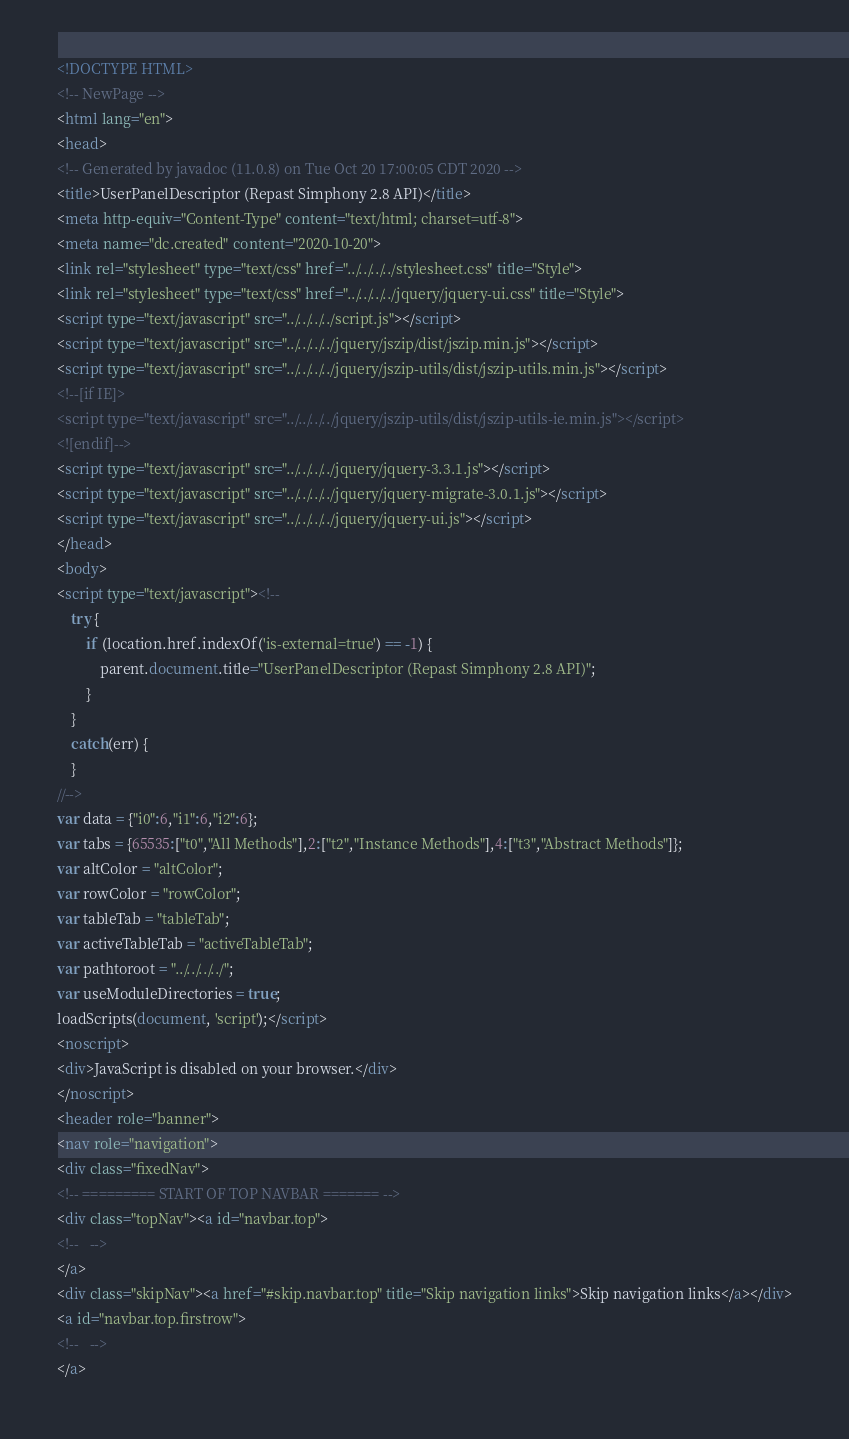<code> <loc_0><loc_0><loc_500><loc_500><_HTML_><!DOCTYPE HTML>
<!-- NewPage -->
<html lang="en">
<head>
<!-- Generated by javadoc (11.0.8) on Tue Oct 20 17:00:05 CDT 2020 -->
<title>UserPanelDescriptor (Repast Simphony 2.8 API)</title>
<meta http-equiv="Content-Type" content="text/html; charset=utf-8">
<meta name="dc.created" content="2020-10-20">
<link rel="stylesheet" type="text/css" href="../../../../stylesheet.css" title="Style">
<link rel="stylesheet" type="text/css" href="../../../../jquery/jquery-ui.css" title="Style">
<script type="text/javascript" src="../../../../script.js"></script>
<script type="text/javascript" src="../../../../jquery/jszip/dist/jszip.min.js"></script>
<script type="text/javascript" src="../../../../jquery/jszip-utils/dist/jszip-utils.min.js"></script>
<!--[if IE]>
<script type="text/javascript" src="../../../../jquery/jszip-utils/dist/jszip-utils-ie.min.js"></script>
<![endif]-->
<script type="text/javascript" src="../../../../jquery/jquery-3.3.1.js"></script>
<script type="text/javascript" src="../../../../jquery/jquery-migrate-3.0.1.js"></script>
<script type="text/javascript" src="../../../../jquery/jquery-ui.js"></script>
</head>
<body>
<script type="text/javascript"><!--
    try {
        if (location.href.indexOf('is-external=true') == -1) {
            parent.document.title="UserPanelDescriptor (Repast Simphony 2.8 API)";
        }
    }
    catch(err) {
    }
//-->
var data = {"i0":6,"i1":6,"i2":6};
var tabs = {65535:["t0","All Methods"],2:["t2","Instance Methods"],4:["t3","Abstract Methods"]};
var altColor = "altColor";
var rowColor = "rowColor";
var tableTab = "tableTab";
var activeTableTab = "activeTableTab";
var pathtoroot = "../../../../";
var useModuleDirectories = true;
loadScripts(document, 'script');</script>
<noscript>
<div>JavaScript is disabled on your browser.</div>
</noscript>
<header role="banner">
<nav role="navigation">
<div class="fixedNav">
<!-- ========= START OF TOP NAVBAR ======= -->
<div class="topNav"><a id="navbar.top">
<!--   -->
</a>
<div class="skipNav"><a href="#skip.navbar.top" title="Skip navigation links">Skip navigation links</a></div>
<a id="navbar.top.firstrow">
<!--   -->
</a></code> 